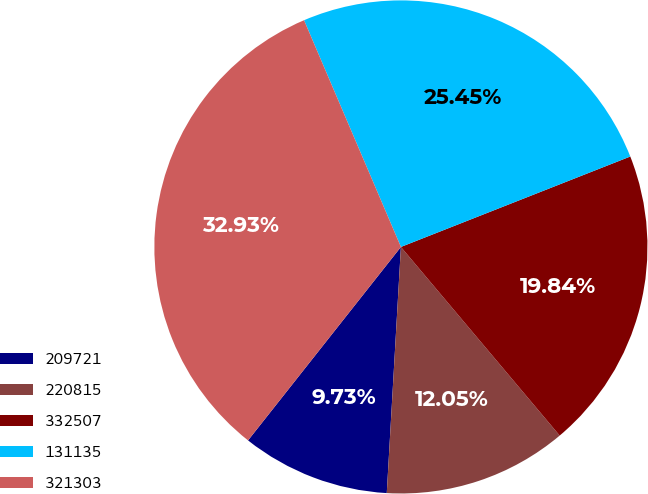Convert chart to OTSL. <chart><loc_0><loc_0><loc_500><loc_500><pie_chart><fcel>209721<fcel>220815<fcel>332507<fcel>131135<fcel>321303<nl><fcel>9.73%<fcel>12.05%<fcel>19.84%<fcel>25.45%<fcel>32.93%<nl></chart> 